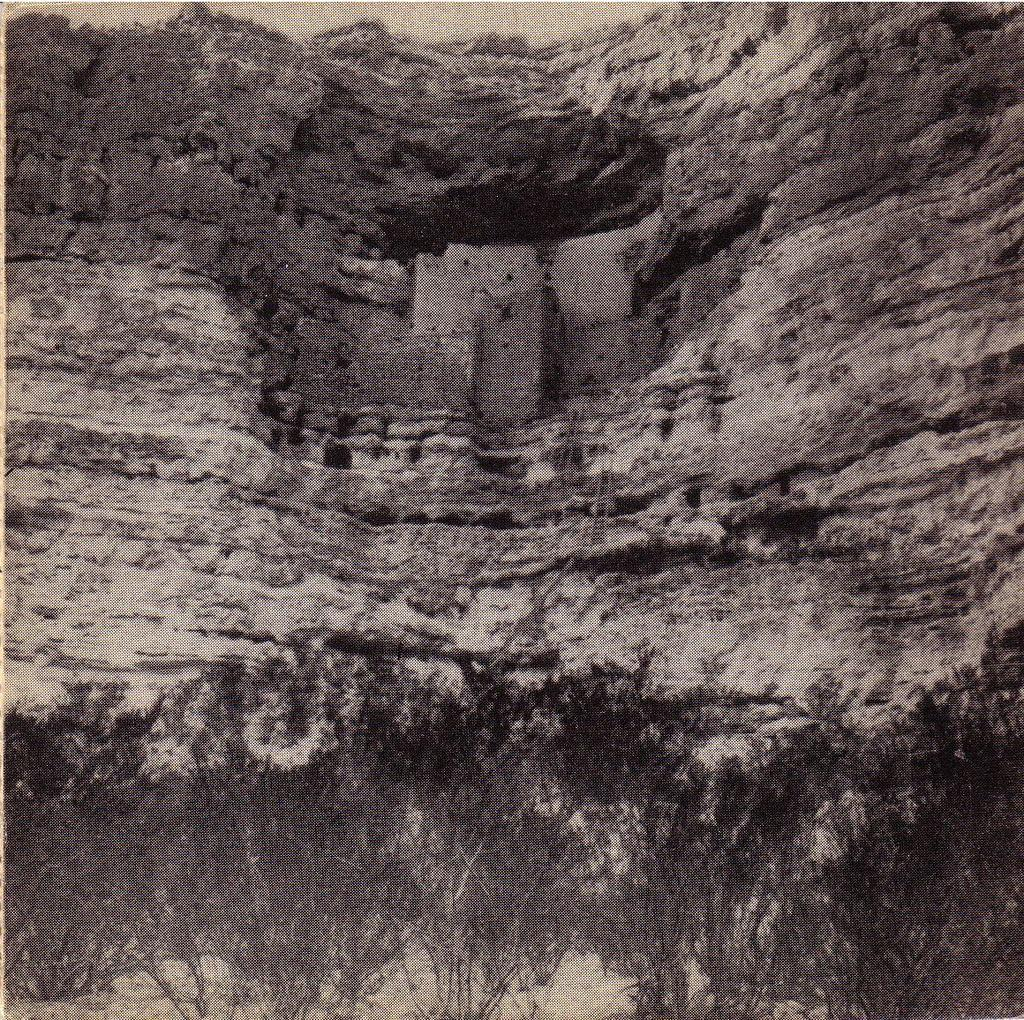What type of visual is the image? The image is a poster. What natural elements can be seen in the poster? There are trees visible in the image. What man-made structure is present in the poster? There is a wall visible in the image. What type of gun is hanging on the roof in the image? There is no gun or roof present in the image; it only features a poster with trees and a wall. 